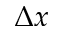<formula> <loc_0><loc_0><loc_500><loc_500>\Delta x</formula> 